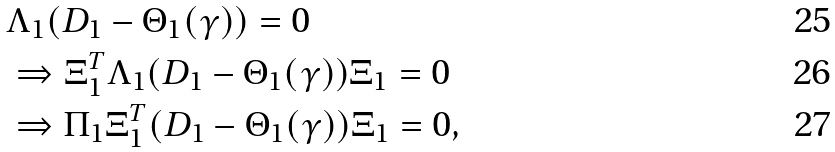Convert formula to latex. <formula><loc_0><loc_0><loc_500><loc_500>& \Lambda _ { 1 } ( D _ { 1 } - \Theta _ { 1 } ( \gamma ) ) = 0 \\ & \Rightarrow \Xi ^ { T } _ { 1 } \Lambda _ { 1 } ( D _ { 1 } - \Theta _ { 1 } ( \gamma ) ) \Xi _ { 1 } = 0 \\ & \Rightarrow \Pi _ { 1 } \Xi ^ { T } _ { 1 } ( D _ { 1 } - \Theta _ { 1 } ( \gamma ) ) \Xi _ { 1 } = 0 ,</formula> 